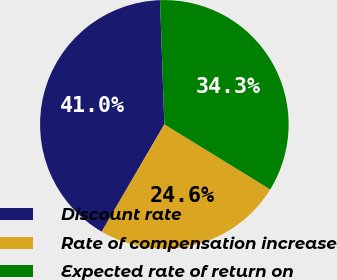<chart> <loc_0><loc_0><loc_500><loc_500><pie_chart><fcel>Discount rate<fcel>Rate of compensation increase<fcel>Expected rate of return on<nl><fcel>41.05%<fcel>24.63%<fcel>34.32%<nl></chart> 